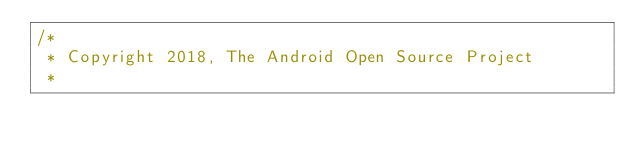Convert code to text. <code><loc_0><loc_0><loc_500><loc_500><_Kotlin_>/*
 * Copyright 2018, The Android Open Source Project
 *</code> 